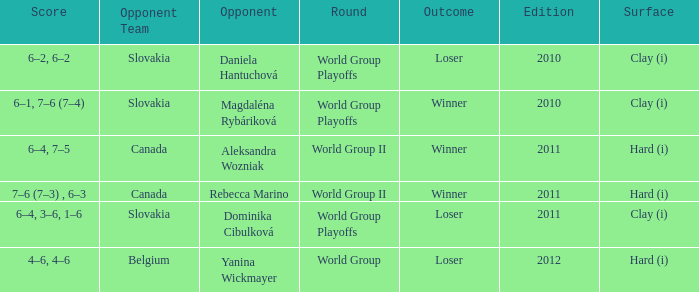How many outcomes were there when the opponent was Aleksandra Wozniak? 1.0. 